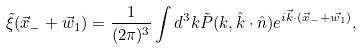<formula> <loc_0><loc_0><loc_500><loc_500>\tilde { \xi } ( \vec { x } _ { - } + \vec { w } _ { 1 } ) = \frac { 1 } { ( 2 \pi ) ^ { 3 } } \int d ^ { 3 } k \tilde { P } ( k , \hat { k } \cdot \hat { n } ) e ^ { i \vec { k } \cdot ( \vec { x } _ { - } + \vec { w _ { 1 } } ) } ,</formula> 